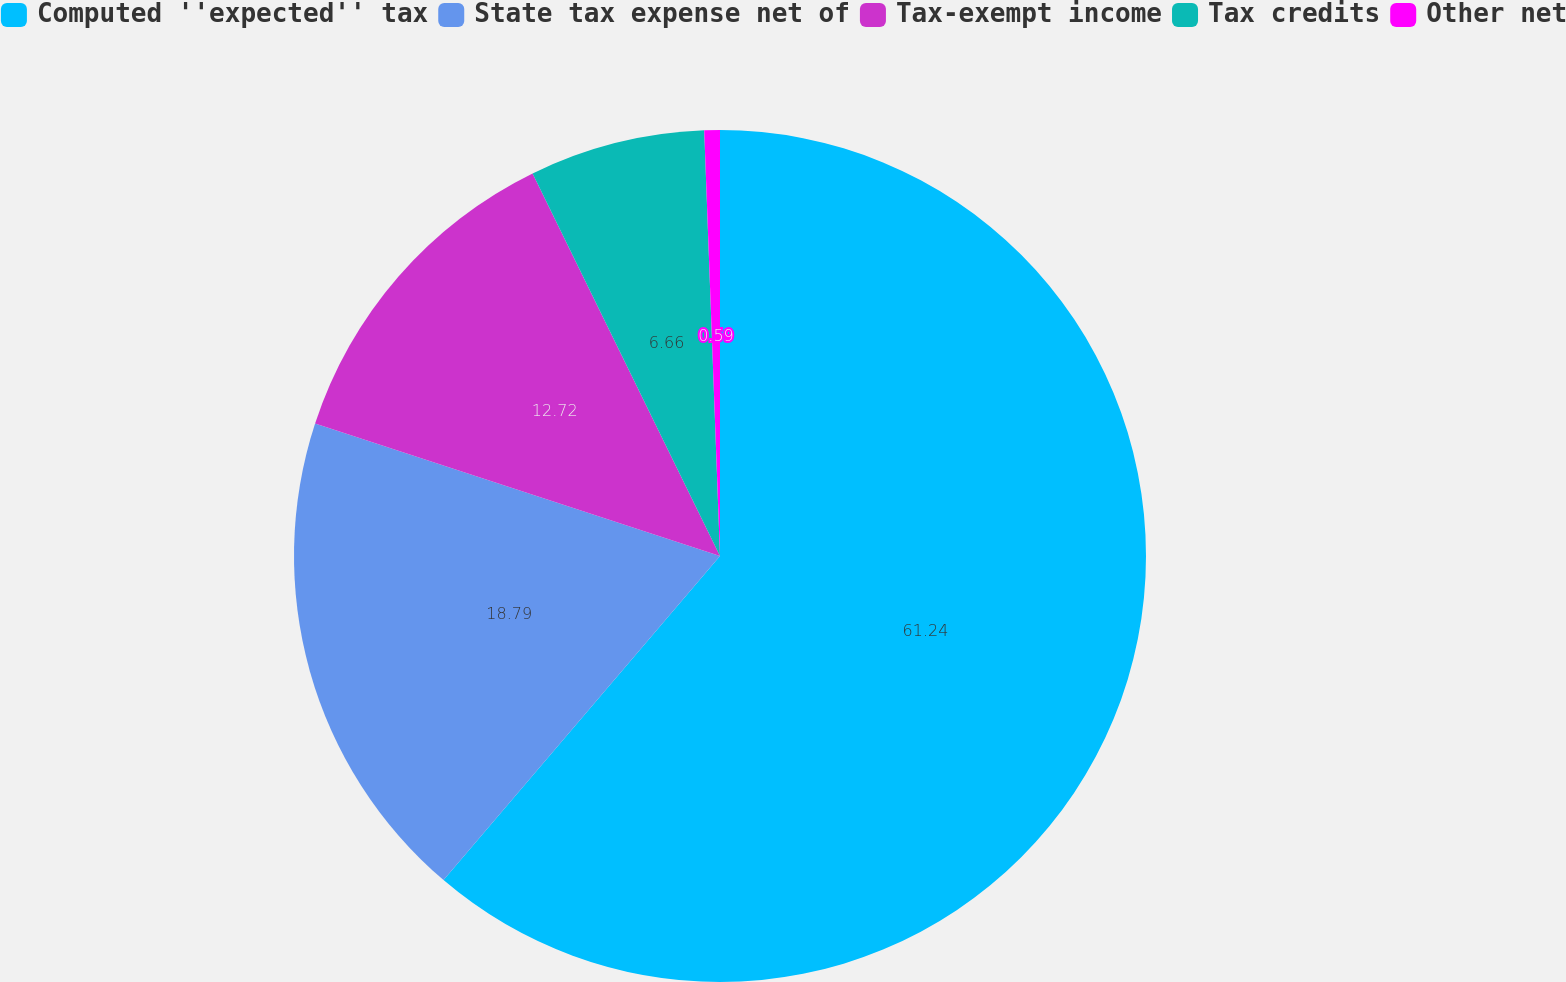<chart> <loc_0><loc_0><loc_500><loc_500><pie_chart><fcel>Computed ''expected'' tax<fcel>State tax expense net of<fcel>Tax-exempt income<fcel>Tax credits<fcel>Other net<nl><fcel>61.24%<fcel>18.79%<fcel>12.72%<fcel>6.66%<fcel>0.59%<nl></chart> 